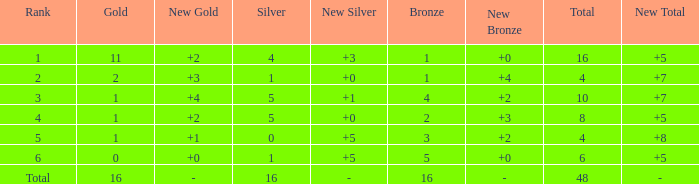How many total gold are less than 4? 0.0. 